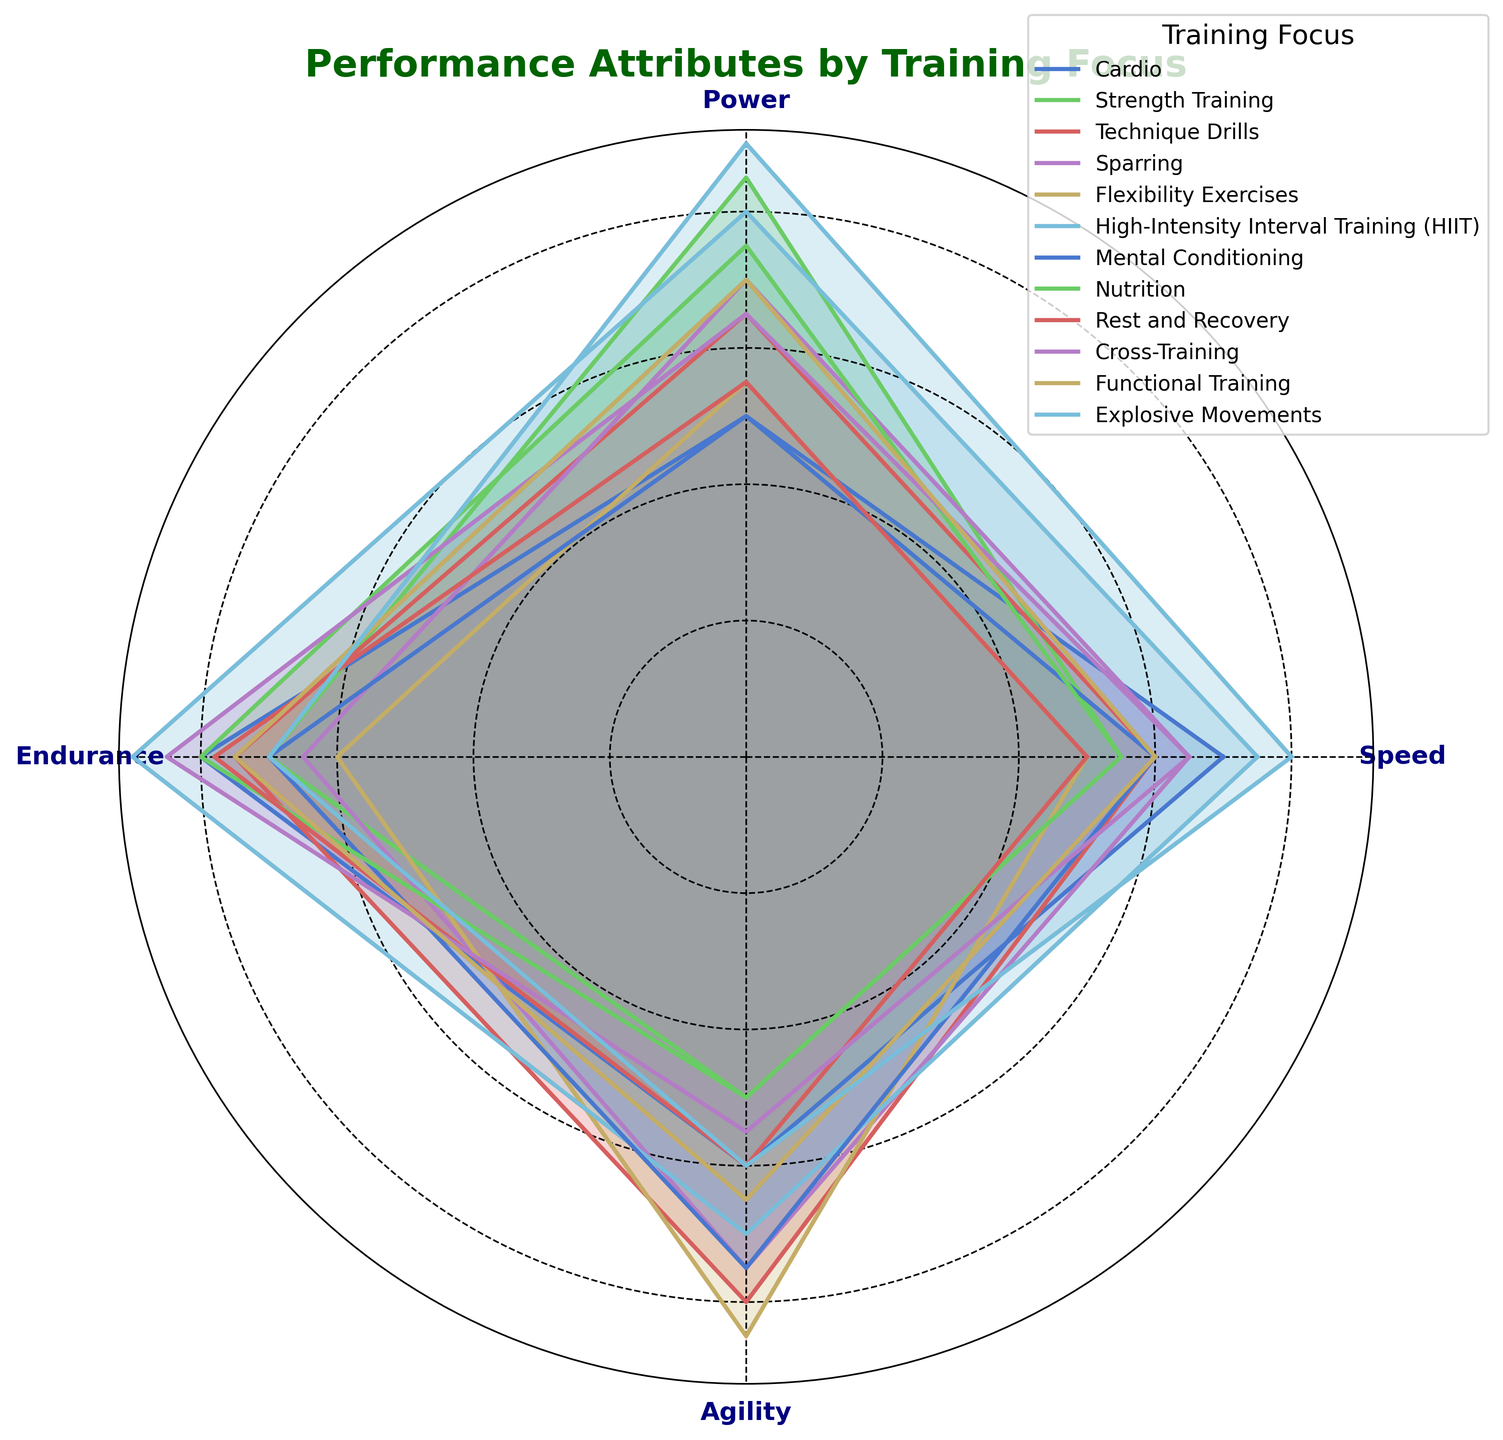What's the highest speed score among all training focuses? To determine the highest speed score, look at the speed values for all training focuses. The scores are: 70, 55, 60, 65, 50, 75, 60, 55, 50, 65, 60, 80. The highest value is 80 from Explosive Movements.
Answer: 80 Which training focus has the lowest agility score? To find the lowest agility score, compare the agility values for all training focuses. The scores are: 60, 50, 80, 75, 85, 70, 75, 50, 60, 55, 65, 60. The lowest value is 50, which comes from Strength Training and Nutrition.
Answer: Strength Training and Nutrition Does High-Intensity Interval Training (HIIT) have higher power or endurance? Compare the power and endurance values for HIIT. The power score is 80, and the endurance score is 90. 90 is higher than 80.
Answer: Endurance What is the average power score for Technique Drills and Functional Training? To find the average, sum the power values for Technique Drills (65) and Functional Training (70). The total is 65 + 70 = 135. The average is 135 / 2 = 67.5.
Answer: 67.5 Which training focus has the highest overall average score for all four attributes? Calculate the average scores for each training focus. Cardio: (70+50+80+60)/4 = 65. Strength Training: (55+85+70+50)/4 = 65. Technique Drills: (60+65+75+80)/4 = 70. Sparring: (65+70+65+75)/4 = 68.75. Flexibility Exercises: (50+55+60+85)/4 = 62.5. HIIT: (75+80+90+70)/4 = 78.75. Mental Conditioning: (60+50+70+75)/4 = 63.75. Nutrition: (55+75+80+50)/4 = 65. Rest and Recovery: (50+55+78+60)/4 = 60.75. Cross-Training: (65+65+85+55)/4 = 67.5. Functional Training: (60+70+75+65)/4 = 67.5. Explosive Movements: (80+90+70+60)/4 = 75. The highest average is 78.75 from HIIT.
Answer: High-Intensity Interval Training (HIIT) How many training focuses have an endurance score greater than 75? Count the number of training focuses where the endurance value exceeds 75. Cardio (80), Technique Drills (75), HIIT (90), Nutrition (80), and Cross-Training (85). This gives us 5 training focuses.
Answer: 5 What is the difference in agility between Flexibility Exercises and Sparring? Compare the agility values for Flexibility Exercises and Sparring. Flexibility Exercises have an agility score of 85, and Sparring has 75. The difference is 85 - 75 = 10.
Answer: 10 Which training focus emphasizes speed the most? Look for the highest speed score. The scores are: 70, 55, 60, 65, 50, 75, 60, 55, 50, 65, 60, 80. The highest score is 80, from Explosive Movements.
Answer: Explosive Movements What's the sum of speed and agility scores for Cardio? Add the speed and agility values for Cardio. Speed is 70 and agility is 60. The sum is 70 + 60 = 130.
Answer: 130 